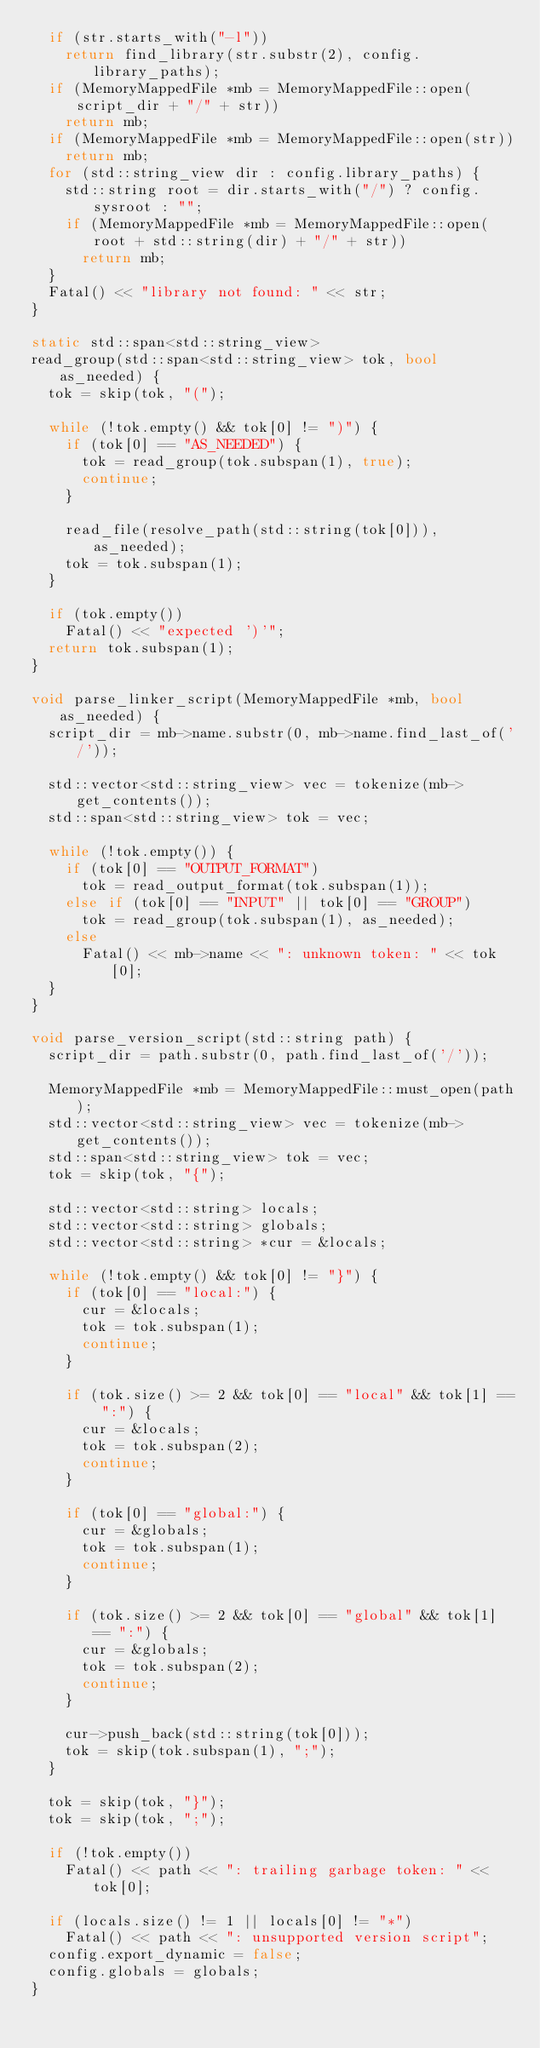<code> <loc_0><loc_0><loc_500><loc_500><_C++_>  if (str.starts_with("-l"))
    return find_library(str.substr(2), config.library_paths);
  if (MemoryMappedFile *mb = MemoryMappedFile::open(script_dir + "/" + str))
    return mb;
  if (MemoryMappedFile *mb = MemoryMappedFile::open(str))
    return mb;
  for (std::string_view dir : config.library_paths) {
    std::string root = dir.starts_with("/") ? config.sysroot : "";
    if (MemoryMappedFile *mb = MemoryMappedFile::open(root + std::string(dir) + "/" + str))
      return mb;
  }
  Fatal() << "library not found: " << str;
}

static std::span<std::string_view>
read_group(std::span<std::string_view> tok, bool as_needed) {
  tok = skip(tok, "(");

  while (!tok.empty() && tok[0] != ")") {
    if (tok[0] == "AS_NEEDED") {
      tok = read_group(tok.subspan(1), true);
      continue;
    }

    read_file(resolve_path(std::string(tok[0])), as_needed);
    tok = tok.subspan(1);
  }

  if (tok.empty())
    Fatal() << "expected ')'";
  return tok.subspan(1);
}

void parse_linker_script(MemoryMappedFile *mb, bool as_needed) {
  script_dir = mb->name.substr(0, mb->name.find_last_of('/'));

  std::vector<std::string_view> vec = tokenize(mb->get_contents());
  std::span<std::string_view> tok = vec;

  while (!tok.empty()) {
    if (tok[0] == "OUTPUT_FORMAT")
      tok = read_output_format(tok.subspan(1));
    else if (tok[0] == "INPUT" || tok[0] == "GROUP")
      tok = read_group(tok.subspan(1), as_needed);
    else
      Fatal() << mb->name << ": unknown token: " << tok[0];
  }
}

void parse_version_script(std::string path) {
  script_dir = path.substr(0, path.find_last_of('/'));

  MemoryMappedFile *mb = MemoryMappedFile::must_open(path);
  std::vector<std::string_view> vec = tokenize(mb->get_contents());
  std::span<std::string_view> tok = vec;
  tok = skip(tok, "{");

  std::vector<std::string> locals;
  std::vector<std::string> globals;
  std::vector<std::string> *cur = &locals;

  while (!tok.empty() && tok[0] != "}") {
    if (tok[0] == "local:") {
      cur = &locals;
      tok = tok.subspan(1);
      continue;
    }

    if (tok.size() >= 2 && tok[0] == "local" && tok[1] == ":") {
      cur = &locals;
      tok = tok.subspan(2);
      continue;
    }

    if (tok[0] == "global:") {
      cur = &globals;
      tok = tok.subspan(1);
      continue;
    }

    if (tok.size() >= 2 && tok[0] == "global" && tok[1] == ":") {
      cur = &globals;
      tok = tok.subspan(2);
      continue;
    }

    cur->push_back(std::string(tok[0]));
    tok = skip(tok.subspan(1), ";");
  }

  tok = skip(tok, "}");
  tok = skip(tok, ";");

  if (!tok.empty())
    Fatal() << path << ": trailing garbage token: " << tok[0];

  if (locals.size() != 1 || locals[0] != "*")
    Fatal() << path << ": unsupported version script";
  config.export_dynamic = false;
  config.globals = globals;
}
</code> 